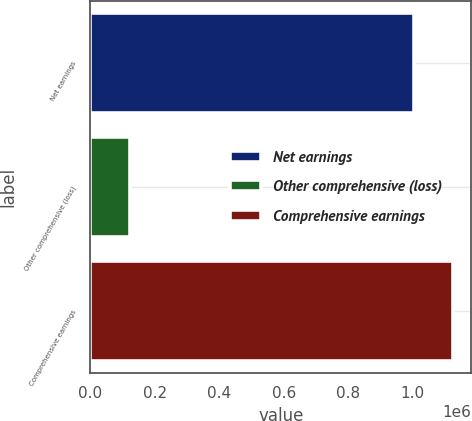<chart> <loc_0><loc_0><loc_500><loc_500><bar_chart><fcel>Net earnings<fcel>Other comprehensive (loss)<fcel>Comprehensive earnings<nl><fcel>1.00313e+06<fcel>122629<fcel>1.12576e+06<nl></chart> 